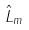<formula> <loc_0><loc_0><loc_500><loc_500>\hat { L } _ { m }</formula> 